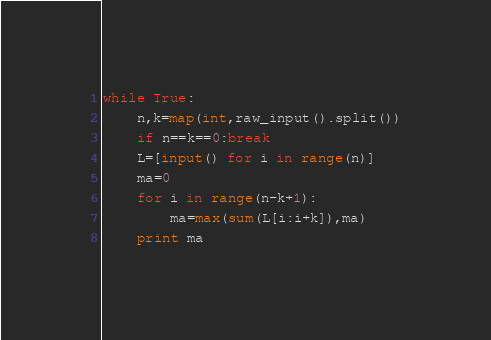Convert code to text. <code><loc_0><loc_0><loc_500><loc_500><_Python_>while True:
    n,k=map(int,raw_input().split())
    if n==k==0:break
    L=[input() for i in range(n)]
    ma=0
    for i in range(n-k+1):
        ma=max(sum(L[i:i+k]),ma)
    print ma</code> 